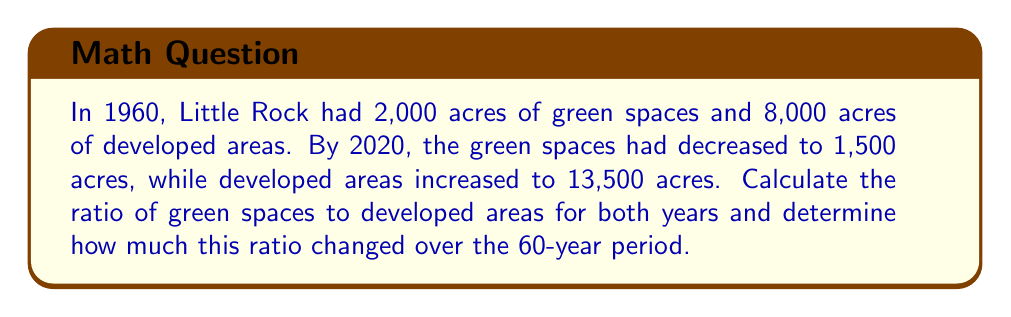Show me your answer to this math problem. 1. Calculate the ratio of green spaces to developed areas in 1960:
   $$\text{Ratio}_{1960} = \frac{\text{Green Spaces}}{\text{Developed Areas}} = \frac{2000}{8000} = \frac{1}{4}$$

2. Calculate the ratio of green spaces to developed areas in 2020:
   $$\text{Ratio}_{2020} = \frac{\text{Green Spaces}}{\text{Developed Areas}} = \frac{1500}{13500} = \frac{1}{9}$$

3. To find how much the ratio changed, subtract the 2020 ratio from the 1960 ratio:
   $$\text{Change in Ratio} = \text{Ratio}_{1960} - \text{Ratio}_{2020} = \frac{1}{4} - \frac{1}{9}$$

4. To subtract fractions with different denominators, we need a common denominator:
   $$\frac{1}{4} - \frac{1}{9} = \frac{9}{36} - \frac{4}{36} = \frac{5}{36}$$

Therefore, the ratio of green spaces to developed areas decreased by $\frac{5}{36}$ over the 60-year period.
Answer: $\frac{5}{36}$ 